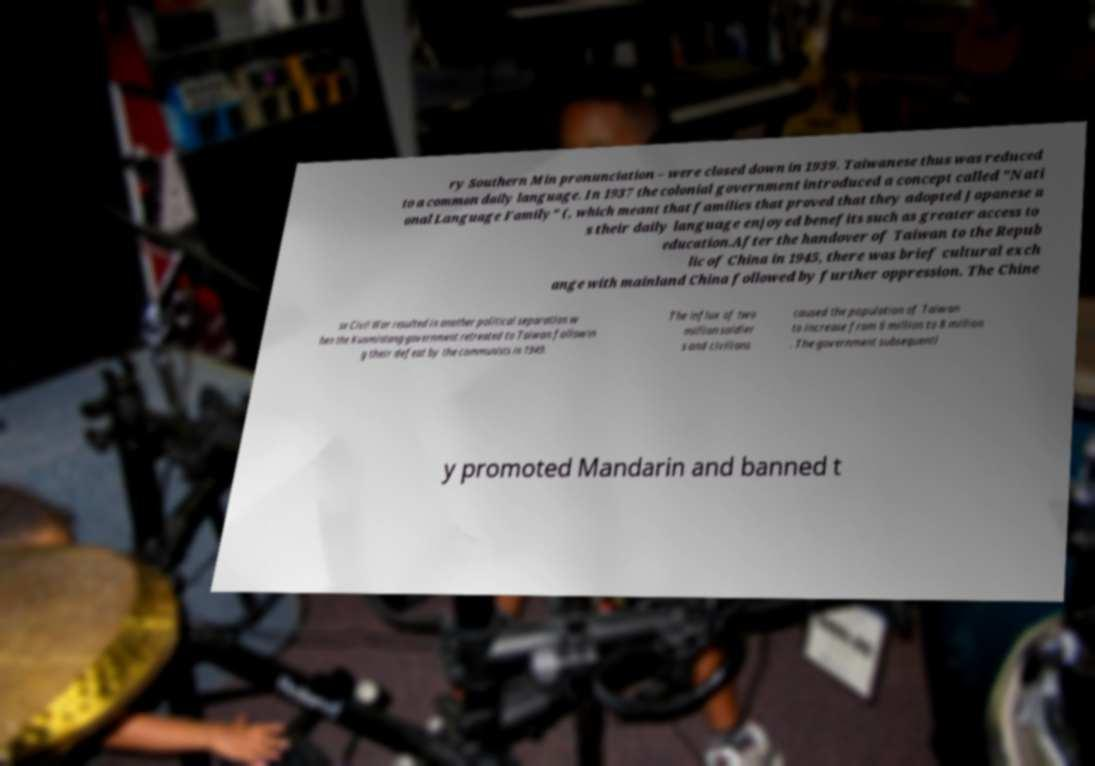There's text embedded in this image that I need extracted. Can you transcribe it verbatim? ry Southern Min pronunciation – were closed down in 1939. Taiwanese thus was reduced to a common daily language. In 1937 the colonial government introduced a concept called "Nati onal Language Family" (, which meant that families that proved that they adopted Japanese a s their daily language enjoyed benefits such as greater access to education.After the handover of Taiwan to the Repub lic of China in 1945, there was brief cultural exch ange with mainland China followed by further oppression. The Chine se Civil War resulted in another political separation w hen the Kuomintang government retreated to Taiwan followin g their defeat by the communists in 1949. The influx of two million soldier s and civilians caused the population of Taiwan to increase from 6 million to 8 million . The government subsequentl y promoted Mandarin and banned t 